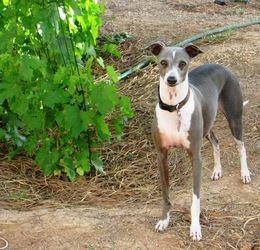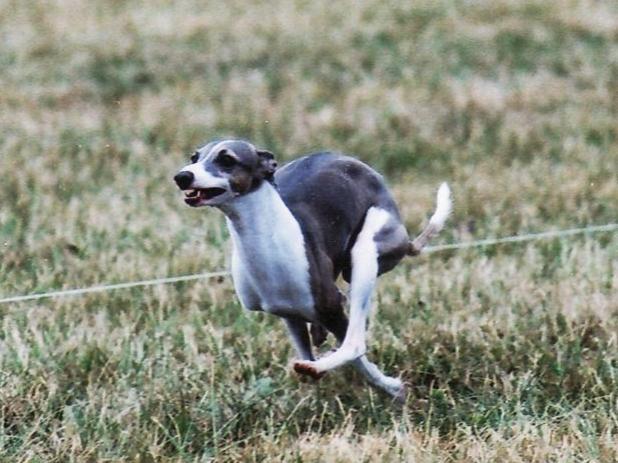The first image is the image on the left, the second image is the image on the right. Assess this claim about the two images: "One of the paired images shows multiple black and white dogs.". Correct or not? Answer yes or no. No. 